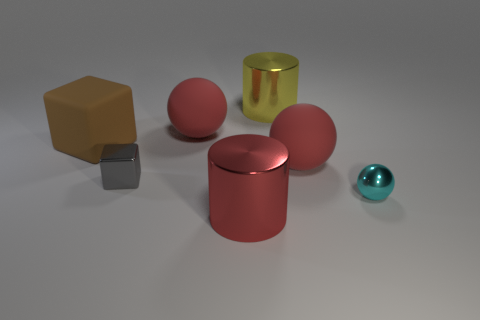What material is the gray thing that is the same size as the cyan thing?
Keep it short and to the point. Metal. Does the red object in front of the gray metallic cube have the same size as the yellow cylinder?
Provide a succinct answer. Yes. What number of blocks are small cyan things or big brown objects?
Keep it short and to the point. 1. There is a cylinder behind the gray shiny thing; what is it made of?
Provide a succinct answer. Metal. Is the number of large metal cylinders less than the number of small cyan balls?
Ensure brevity in your answer.  No. There is a object that is behind the brown block and right of the red metallic cylinder; what size is it?
Your answer should be very brief. Large. There is a shiny object that is to the right of the metallic object behind the red rubber object that is left of the yellow shiny thing; what size is it?
Make the answer very short. Small. What number of other objects are the same color as the tiny block?
Provide a succinct answer. 0. What number of things are rubber objects or large yellow cylinders?
Ensure brevity in your answer.  4. What color is the small thing that is behind the tiny cyan metallic object?
Your answer should be compact. Gray. 